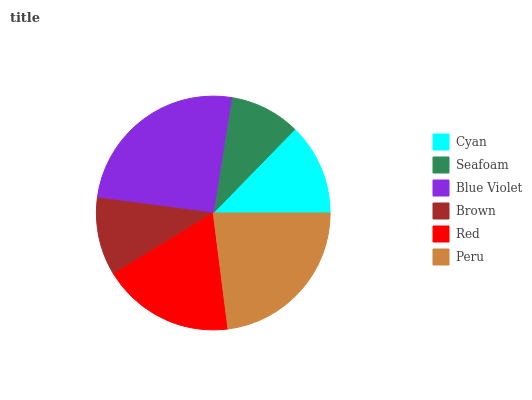Is Seafoam the minimum?
Answer yes or no. Yes. Is Blue Violet the maximum?
Answer yes or no. Yes. Is Blue Violet the minimum?
Answer yes or no. No. Is Seafoam the maximum?
Answer yes or no. No. Is Blue Violet greater than Seafoam?
Answer yes or no. Yes. Is Seafoam less than Blue Violet?
Answer yes or no. Yes. Is Seafoam greater than Blue Violet?
Answer yes or no. No. Is Blue Violet less than Seafoam?
Answer yes or no. No. Is Red the high median?
Answer yes or no. Yes. Is Cyan the low median?
Answer yes or no. Yes. Is Blue Violet the high median?
Answer yes or no. No. Is Seafoam the low median?
Answer yes or no. No. 